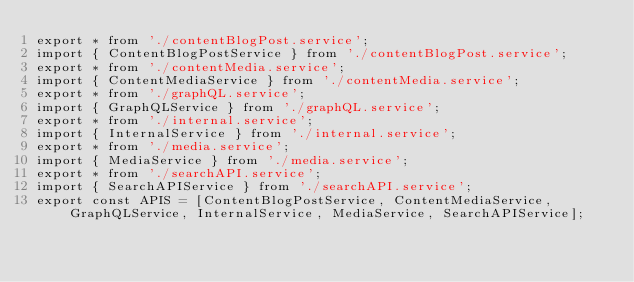<code> <loc_0><loc_0><loc_500><loc_500><_JavaScript_>export * from './contentBlogPost.service';
import { ContentBlogPostService } from './contentBlogPost.service';
export * from './contentMedia.service';
import { ContentMediaService } from './contentMedia.service';
export * from './graphQL.service';
import { GraphQLService } from './graphQL.service';
export * from './internal.service';
import { InternalService } from './internal.service';
export * from './media.service';
import { MediaService } from './media.service';
export * from './searchAPI.service';
import { SearchAPIService } from './searchAPI.service';
export const APIS = [ContentBlogPostService, ContentMediaService, GraphQLService, InternalService, MediaService, SearchAPIService];</code> 